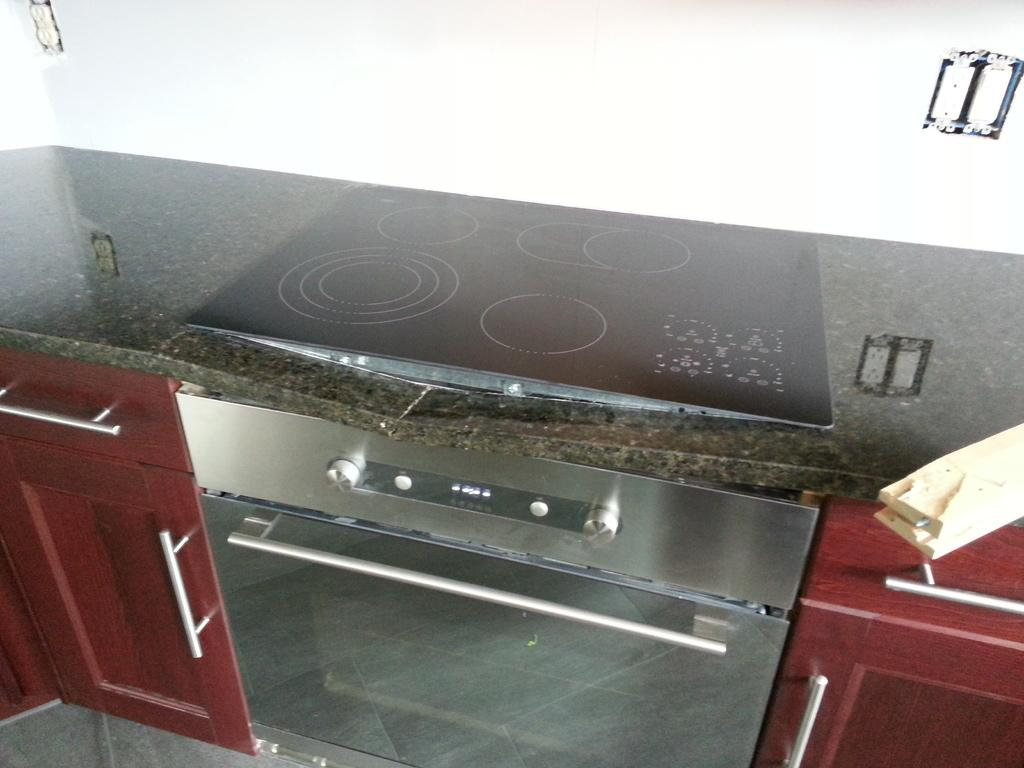What type of furniture is present in the image? There are cupboards in the image. What cooking appliance can be seen in the image? There is a stove on a platform in the image. What surface is visible in the image? The image shows a floor. What can be seen in the background of the image? There is a wall visible in the background of the image. What advice does the owner of the stove give in the image? There is no indication in the image that anyone is giving advice or that there is an owner of the stove. What type of cannon is present in the image? There is no cannon present in the image. 